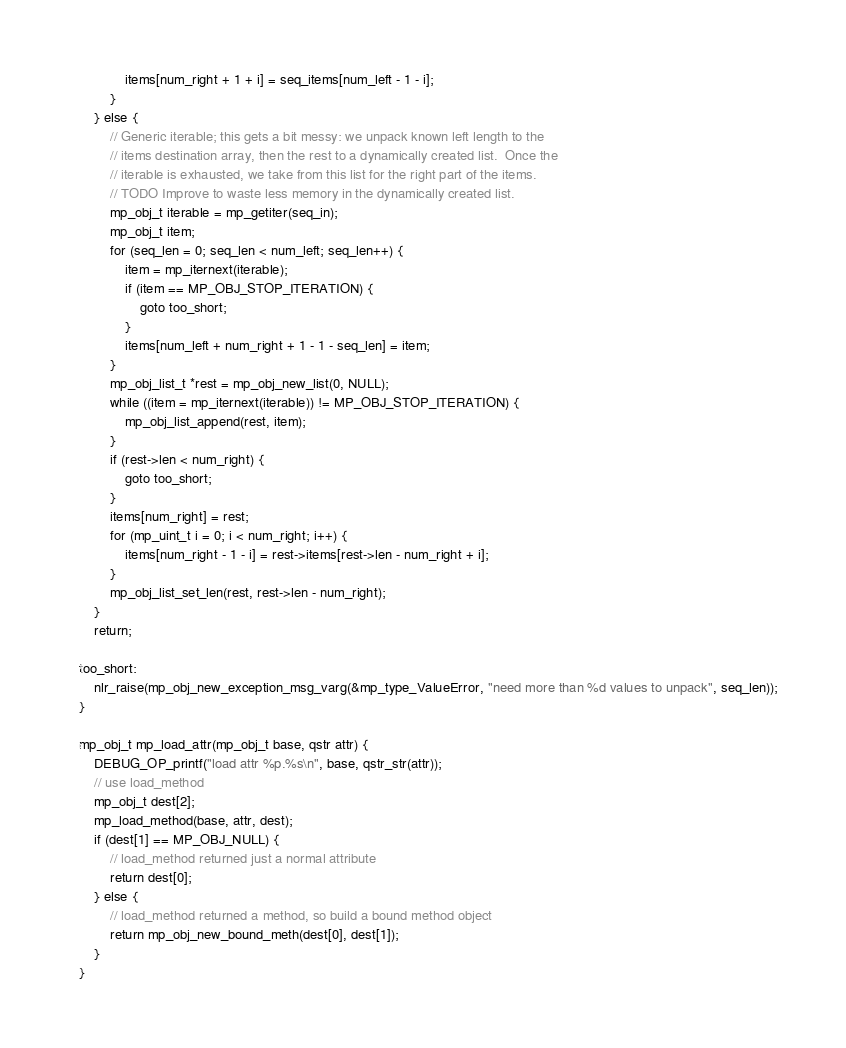<code> <loc_0><loc_0><loc_500><loc_500><_C_>            items[num_right + 1 + i] = seq_items[num_left - 1 - i];
        }
    } else {
        // Generic iterable; this gets a bit messy: we unpack known left length to the
        // items destination array, then the rest to a dynamically created list.  Once the
        // iterable is exhausted, we take from this list for the right part of the items.
        // TODO Improve to waste less memory in the dynamically created list.
        mp_obj_t iterable = mp_getiter(seq_in);
        mp_obj_t item;
        for (seq_len = 0; seq_len < num_left; seq_len++) {
            item = mp_iternext(iterable);
            if (item == MP_OBJ_STOP_ITERATION) {
                goto too_short;
            }
            items[num_left + num_right + 1 - 1 - seq_len] = item;
        }
        mp_obj_list_t *rest = mp_obj_new_list(0, NULL);
        while ((item = mp_iternext(iterable)) != MP_OBJ_STOP_ITERATION) {
            mp_obj_list_append(rest, item);
        }
        if (rest->len < num_right) {
            goto too_short;
        }
        items[num_right] = rest;
        for (mp_uint_t i = 0; i < num_right; i++) {
            items[num_right - 1 - i] = rest->items[rest->len - num_right + i];
        }
        mp_obj_list_set_len(rest, rest->len - num_right);
    }
    return;

too_short:
    nlr_raise(mp_obj_new_exception_msg_varg(&mp_type_ValueError, "need more than %d values to unpack", seq_len));
}

mp_obj_t mp_load_attr(mp_obj_t base, qstr attr) {
    DEBUG_OP_printf("load attr %p.%s\n", base, qstr_str(attr));
    // use load_method
    mp_obj_t dest[2];
    mp_load_method(base, attr, dest);
    if (dest[1] == MP_OBJ_NULL) {
        // load_method returned just a normal attribute
        return dest[0];
    } else {
        // load_method returned a method, so build a bound method object
        return mp_obj_new_bound_meth(dest[0], dest[1]);
    }
}
</code> 